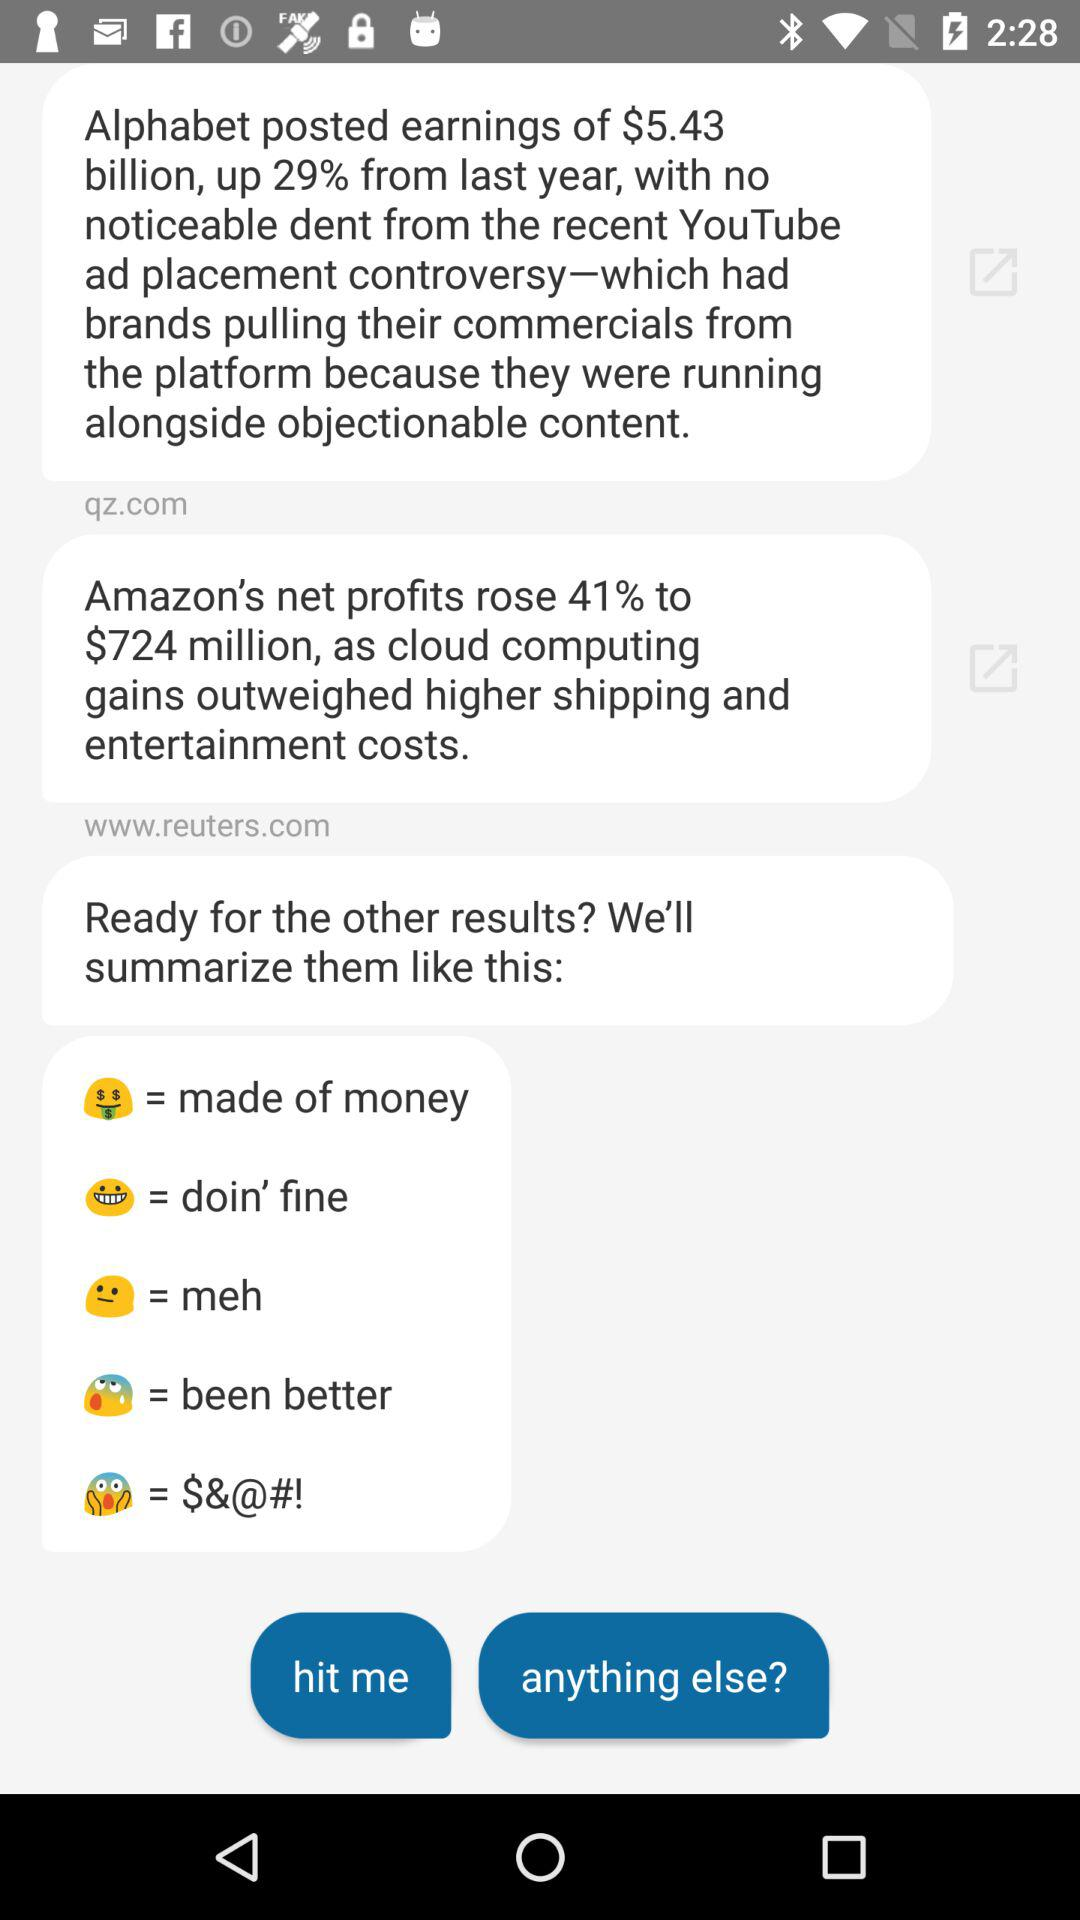How many results are there with a profit increase greater than 20%?
Answer the question using a single word or phrase. 2 